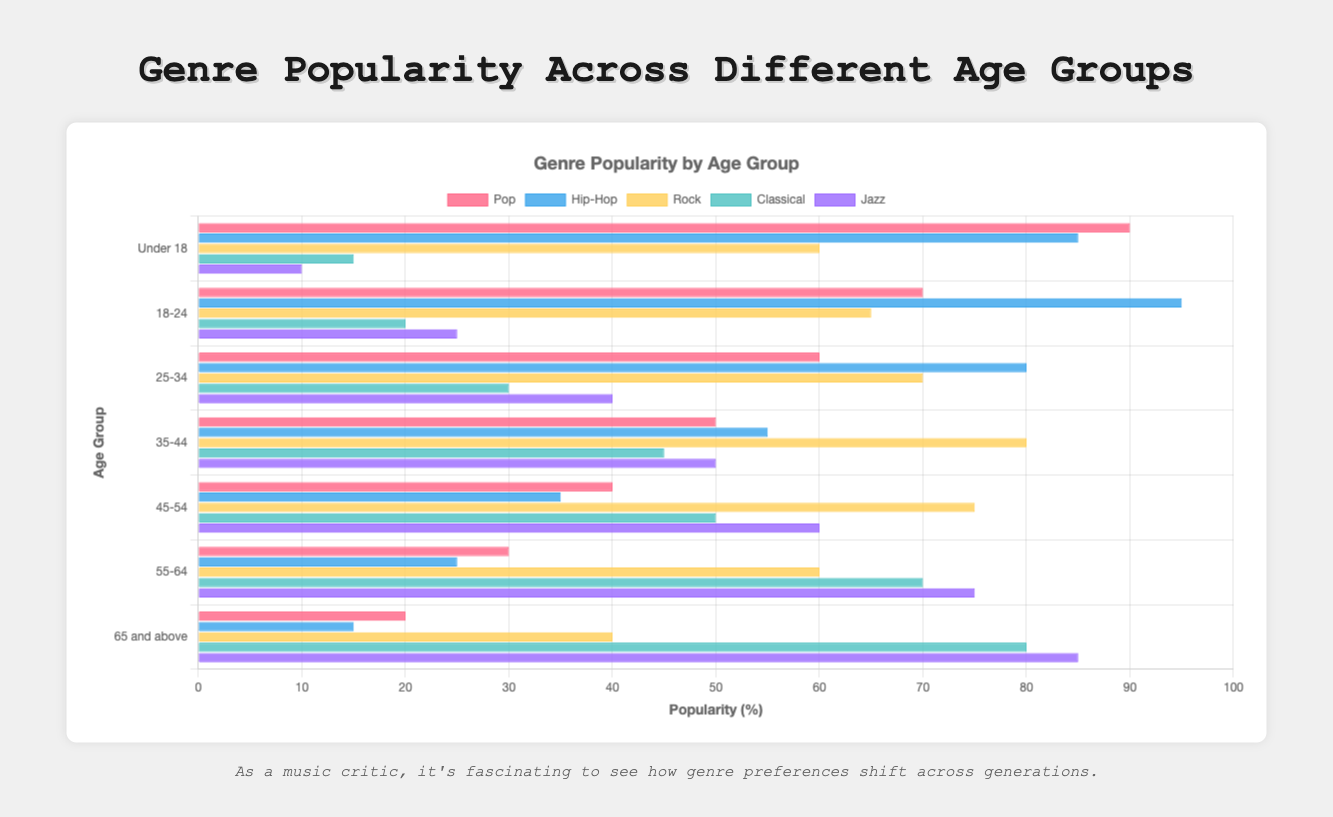Which age group has the highest popularity for Hip-Hop? By looking at the bars for Hip-Hop across all age groups, the bar representing the '18-24' age group is the longest, indicating the highest popularity.
Answer: 18-24 What is the difference in Rock popularity between the Under 18 and 35-44 age groups? The Rock popularity for the Under 18 age group is 60, and for the 35-44 age group is 80. The difference is 80 - 60 = 20.
Answer: 20 Which genre is most popular among the age group 25-34? For the age group 25-34, the longest bar represents Rock at a value of 70.
Answer: Rock Is Classical more popular in the 55-64 age group than Jazz in the 35-44 age group? The Classical bar for the 55-64 age group is at 70, while the Jazz bar for the 35-44 age group is at 50. Therefore, Classical is more popular in the 55-64 age group.
Answer: Yes Which genre has the lowest popularity among the 65 and above age group? The shortest bar for the 65 and above age group is for Hip-Hop, with a value of 15.
Answer: Hip-Hop What is the average popularity of Pop across all age groups? Adding the Pop popularity values across all age groups: 90 + 70 + 60 + 50 + 40 + 30 + 20 = 360, then dividing by the 7 age groups gives 360 / 7 ≈ 51.43.
Answer: 51.43 Compare the popularity of Jazz between the 45-54 and 65 and above age groups. Jazz popularity in the 45-54 age group is 60, and in the 65 and above age group is 85. Clearly, Jazz is more popular in the 65 and above age group.
Answer: 65 and above What is the combined popularity of Classical and Jazz for the 55-64 age group? The Classical popularity for the 55-64 age group is 70, and Jazz is 75. The combined popularity is 70 + 75 = 145.
Answer: 145 What is the least popular genre among the age group 18-24? The shortest bar for the age group 18-24 is Classical, with a value of 20.
Answer: Classical How much more popular is Pop in the Under 18 age group compared to the 35-44 age group? Pop popularity in the Under 18 age group is 90, and in the 35-44 age group is 50. The difference is 90 - 50 = 40.
Answer: 40 